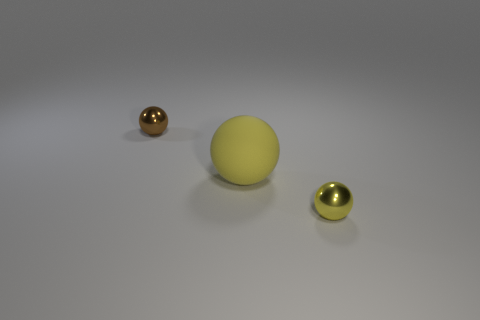There is a rubber sphere; is its size the same as the metal ball that is to the right of the brown thing?
Your answer should be compact. No. Is there a yellow thing of the same size as the rubber sphere?
Offer a terse response. No. What number of other things are there of the same material as the tiny yellow ball
Your response must be concise. 1. What is the color of the thing that is behind the yellow metal object and in front of the brown ball?
Your response must be concise. Yellow. Is the tiny object to the right of the brown shiny thing made of the same material as the tiny ball to the left of the yellow matte object?
Provide a succinct answer. Yes. Do the metal object that is right of the brown thing and the big object have the same size?
Your answer should be compact. No. There is a large rubber ball; is it the same color as the shiny object that is on the right side of the large sphere?
Give a very brief answer. Yes. There is a small object that is the same color as the matte ball; what shape is it?
Provide a succinct answer. Sphere. What number of things are either tiny objects that are left of the tiny yellow shiny ball or tiny yellow balls?
Offer a very short reply. 2. There is a brown sphere that is made of the same material as the small yellow object; what size is it?
Keep it short and to the point. Small. 